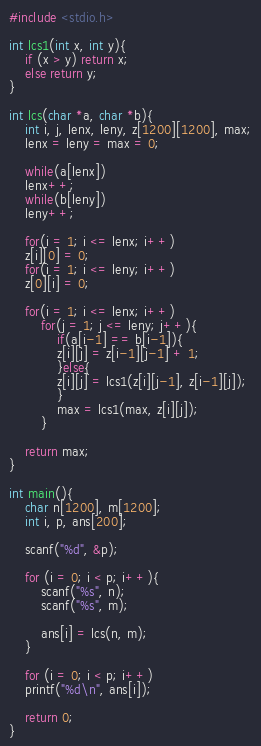<code> <loc_0><loc_0><loc_500><loc_500><_C_>#include <stdio.h>

int lcs1(int x, int y){
	if (x > y) return x;
	else return y;
}
	
int lcs(char *a, char *b){
	int i, j, lenx, leny, z[1200][1200], max;
	lenx = leny = max = 0;
	
	while(a[lenx])
	lenx++;
	while(b[leny])
	leny++;
	
	for(i = 1; i <= lenx; i++)
	z[i][0] = 0;
	for(i = 1; i <= leny; i++)
	z[0][i] = 0;
	
	for(i = 1; i <= lenx; i++)
		for(j = 1; j <= leny; j++){
			if(a[i-1] == b[i-1]){
			z[i][j] = z[i-1][j-1] + 1;
			}else{
			z[i][j] = lcs1(z[i][j-1], z[i-1][j]);
			}
			max = lcs1(max, z[i][j]);
		}
		
	return max;
}

int main(){
	char n[1200], m[1200];
	int i, p, ans[200];
	
	scanf("%d", &p);
	
	for (i = 0; i < p; i++){
		scanf("%s", n);
		scanf("%s", m);
		
		ans[i] = lcs(n, m);
	}
	
	for (i = 0; i < p; i++)
	printf("%d\n", ans[i]);
	
	return 0;
}</code> 